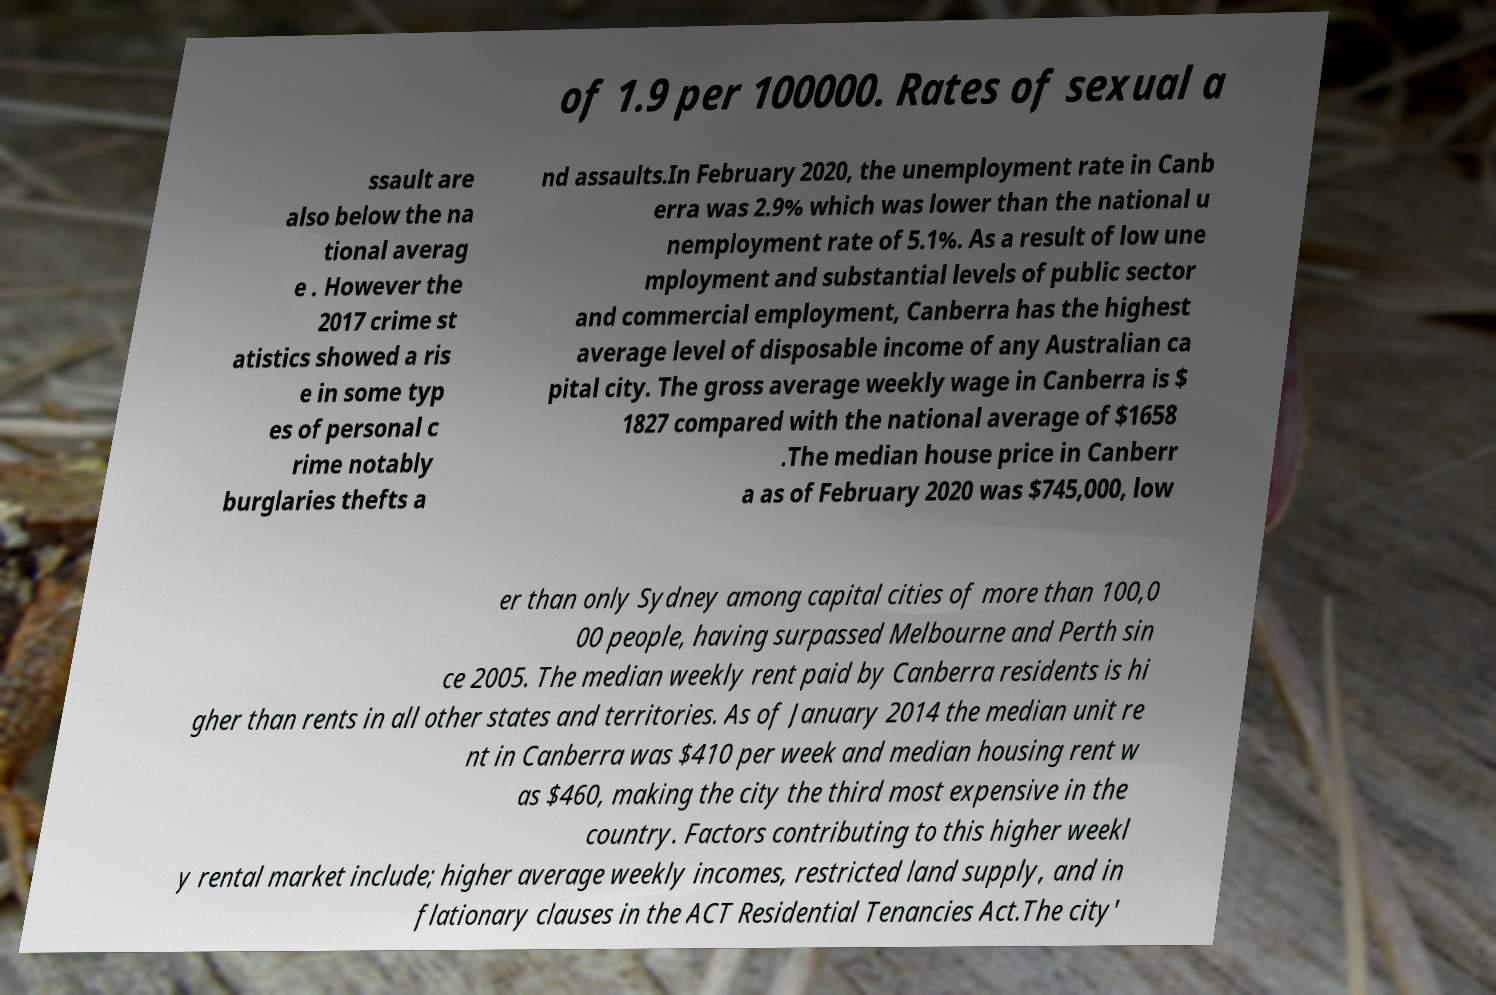I need the written content from this picture converted into text. Can you do that? of 1.9 per 100000. Rates of sexual a ssault are also below the na tional averag e . However the 2017 crime st atistics showed a ris e in some typ es of personal c rime notably burglaries thefts a nd assaults.In February 2020, the unemployment rate in Canb erra was 2.9% which was lower than the national u nemployment rate of 5.1%. As a result of low une mployment and substantial levels of public sector and commercial employment, Canberra has the highest average level of disposable income of any Australian ca pital city. The gross average weekly wage in Canberra is $ 1827 compared with the national average of $1658 .The median house price in Canberr a as of February 2020 was $745,000, low er than only Sydney among capital cities of more than 100,0 00 people, having surpassed Melbourne and Perth sin ce 2005. The median weekly rent paid by Canberra residents is hi gher than rents in all other states and territories. As of January 2014 the median unit re nt in Canberra was $410 per week and median housing rent w as $460, making the city the third most expensive in the country. Factors contributing to this higher weekl y rental market include; higher average weekly incomes, restricted land supply, and in flationary clauses in the ACT Residential Tenancies Act.The city' 